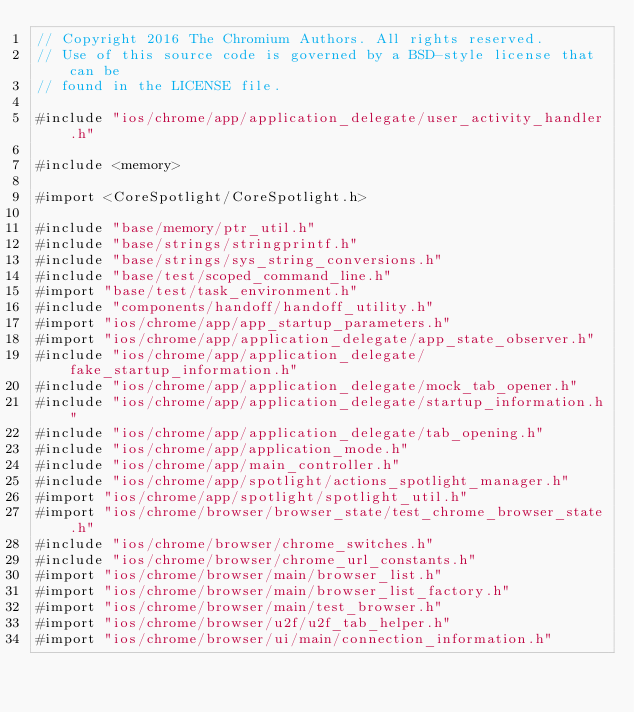Convert code to text. <code><loc_0><loc_0><loc_500><loc_500><_ObjectiveC_>// Copyright 2016 The Chromium Authors. All rights reserved.
// Use of this source code is governed by a BSD-style license that can be
// found in the LICENSE file.

#include "ios/chrome/app/application_delegate/user_activity_handler.h"

#include <memory>

#import <CoreSpotlight/CoreSpotlight.h>

#include "base/memory/ptr_util.h"
#include "base/strings/stringprintf.h"
#include "base/strings/sys_string_conversions.h"
#include "base/test/scoped_command_line.h"
#import "base/test/task_environment.h"
#include "components/handoff/handoff_utility.h"
#import "ios/chrome/app/app_startup_parameters.h"
#import "ios/chrome/app/application_delegate/app_state_observer.h"
#include "ios/chrome/app/application_delegate/fake_startup_information.h"
#include "ios/chrome/app/application_delegate/mock_tab_opener.h"
#include "ios/chrome/app/application_delegate/startup_information.h"
#include "ios/chrome/app/application_delegate/tab_opening.h"
#include "ios/chrome/app/application_mode.h"
#include "ios/chrome/app/main_controller.h"
#include "ios/chrome/app/spotlight/actions_spotlight_manager.h"
#import "ios/chrome/app/spotlight/spotlight_util.h"
#import "ios/chrome/browser/browser_state/test_chrome_browser_state.h"
#include "ios/chrome/browser/chrome_switches.h"
#include "ios/chrome/browser/chrome_url_constants.h"
#import "ios/chrome/browser/main/browser_list.h"
#import "ios/chrome/browser/main/browser_list_factory.h"
#import "ios/chrome/browser/main/test_browser.h"
#import "ios/chrome/browser/u2f/u2f_tab_helper.h"
#import "ios/chrome/browser/ui/main/connection_information.h"</code> 